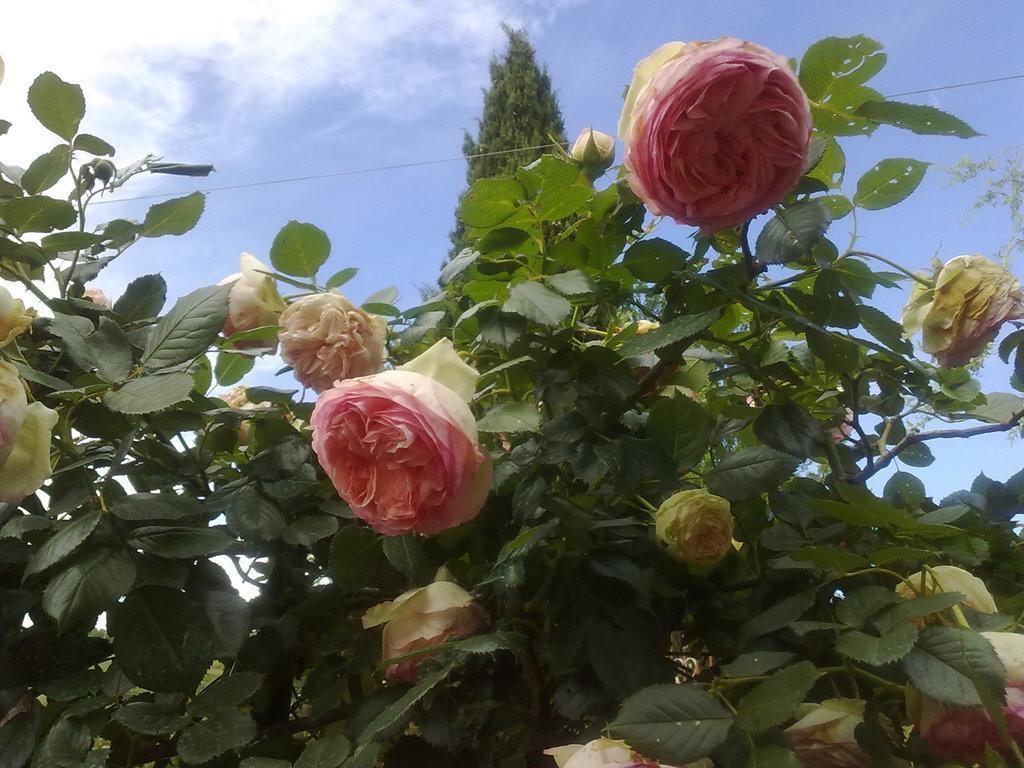Please provide a concise description of this image. In the center of the image there is a flower of a plant. In the background there is sky, tree and clouds. 